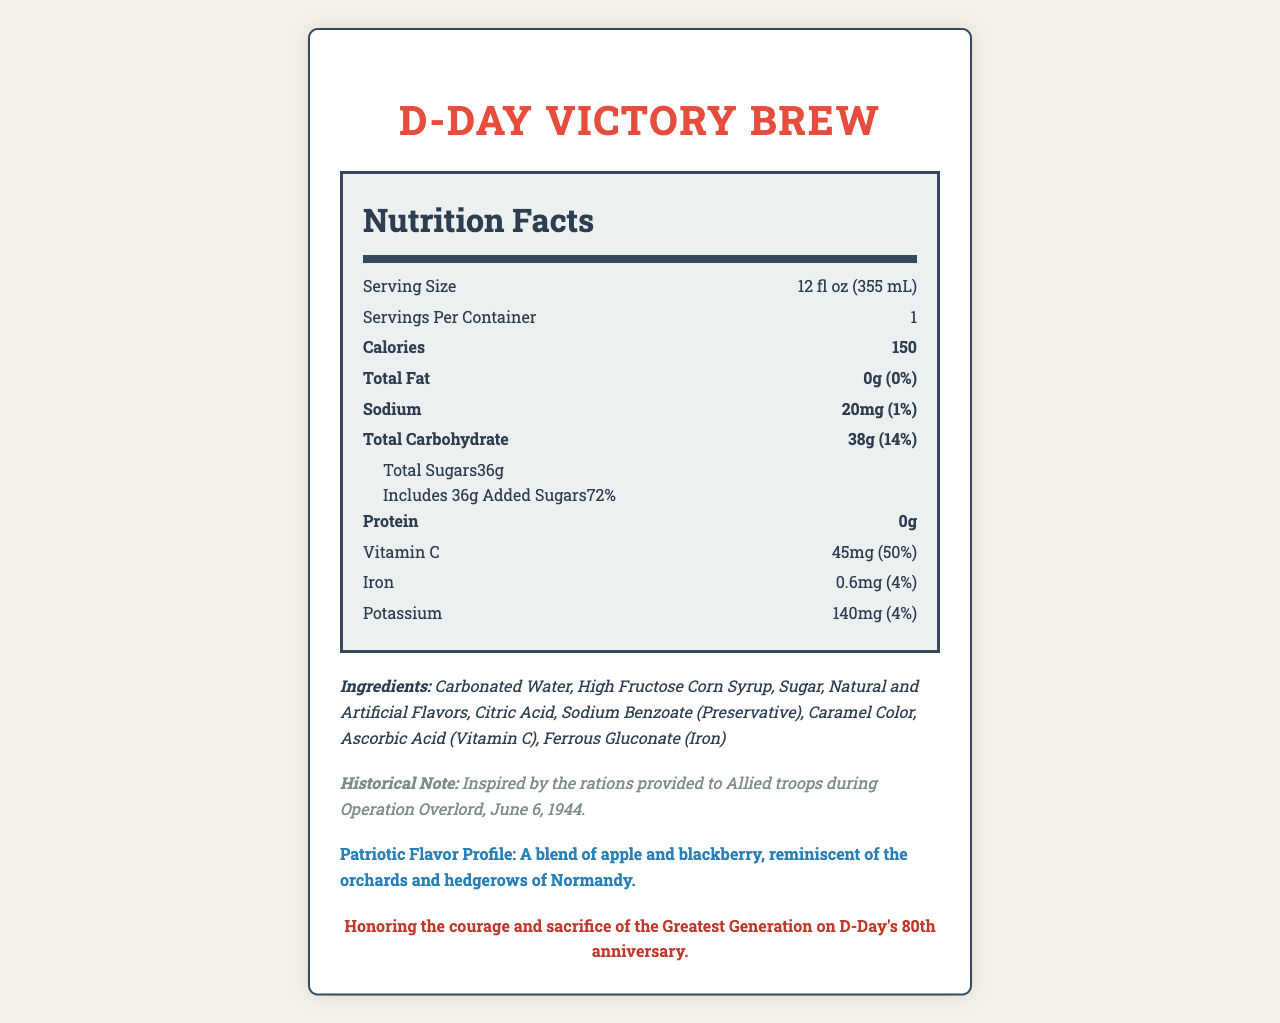what is the serving size? The document lists the serving size as 12 fl oz (355 mL) in the nutrition facts section.
Answer: 12 fl oz (355 mL) what is the amount of Vitamin C in the D-Day Victory Brew? The Nutrition Facts label indicates that the amount of Vitamin C is 45mg.
Answer: 45mg how much added sugar is in this beverage? The nutrition label states that the drink includes 36g of added sugars.
Answer: 36g how many calories does one serving of D-Day Victory Brew contain? The nutrition facts section clearly states that there are 150 calories per serving.
Answer: 150 list three ingredients in the D-Day Victory Brew The ingredients list includes Carbonated Water, High Fructose Corn Syrup, and Sugar among others.
Answer: Carbonated Water, High Fructose Corn Syrup, Sugar what percentage of the daily value of iron does this beverage provide? The nutrition label indicates that the beverage provides 4% of the daily value of iron.
Answer: 4% how much sodium is in one serving? The Nutrition Facts section lists the sodium content as 20mg.
Answer: 20mg which of the following is an ingredient in the D-Day Victory Brew? (A) Ascorbic Acid (B) Milk (C) Gluten (D) Strawberries The ingredient list includes Ascorbic Acid (Vitamin C), but does not mention Milk, Gluten, or Strawberries.
Answer: A what is the flavor profile of the D-Day Victory Brew? (1) Citrus blend (2) Berry medley (3) Apple and blackberry (4) Tropical mix The document describes the flavor profile as a blend of apple and blackberry.
Answer: 3 is this beverage produced in a facility that processes soy and milk? The allergen information indicates that the beverage is produced in a facility that also processes milk and soy.
Answer: Yes what is the main idea of the document? The document includes a Nutrition Facts label, a list of ingredients, and information about the beverage's historical inspiration and special flavor profile.
Answer: The document provides nutritional information, ingredient details, and a historical context for a commemorative D-Day-themed beverage called "D-Day Victory Brew." who is the manufacturer of the D-Day Victory Brew? The document does not provide any information regarding the manufacturer of the beverage.
Answer: Cannot be determined what inspired the creation of the D-Day Victory Brew? The historical note within the document states that it was inspired by the rations provided to Allied troops during Operation Overlord on June 6, 1944.
Answer: Rations provided to Allied troops during Operation Overlord, June 6, 1944 describe the packaging of the D-Day Victory Brew The packaging description mentions an olive drab can with invasion stripes and a silhouette of landing craft approaching the Normandy beaches.
Answer: Olive drab can with invasion stripes, featuring a silhouette of landing craft approaching Normandy beaches 